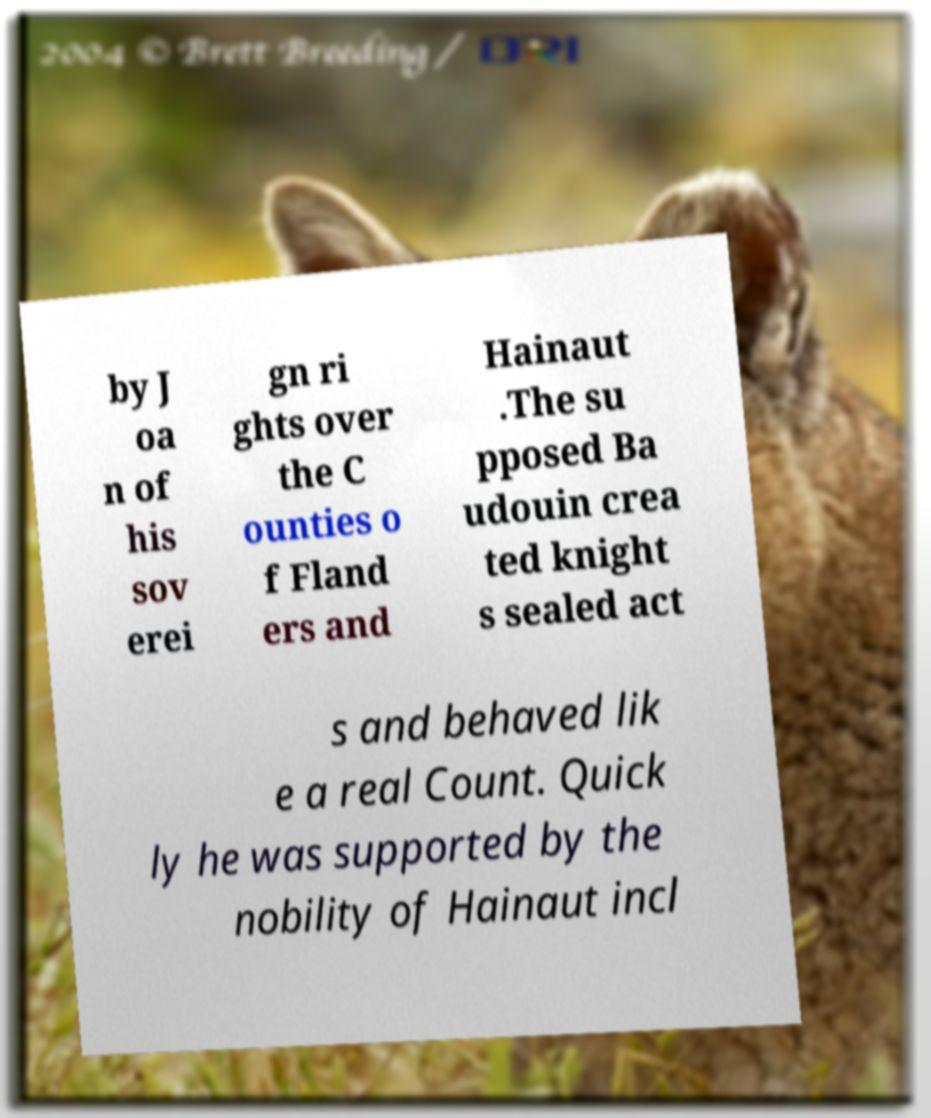Can you accurately transcribe the text from the provided image for me? by J oa n of his sov erei gn ri ghts over the C ounties o f Fland ers and Hainaut .The su pposed Ba udouin crea ted knight s sealed act s and behaved lik e a real Count. Quick ly he was supported by the nobility of Hainaut incl 